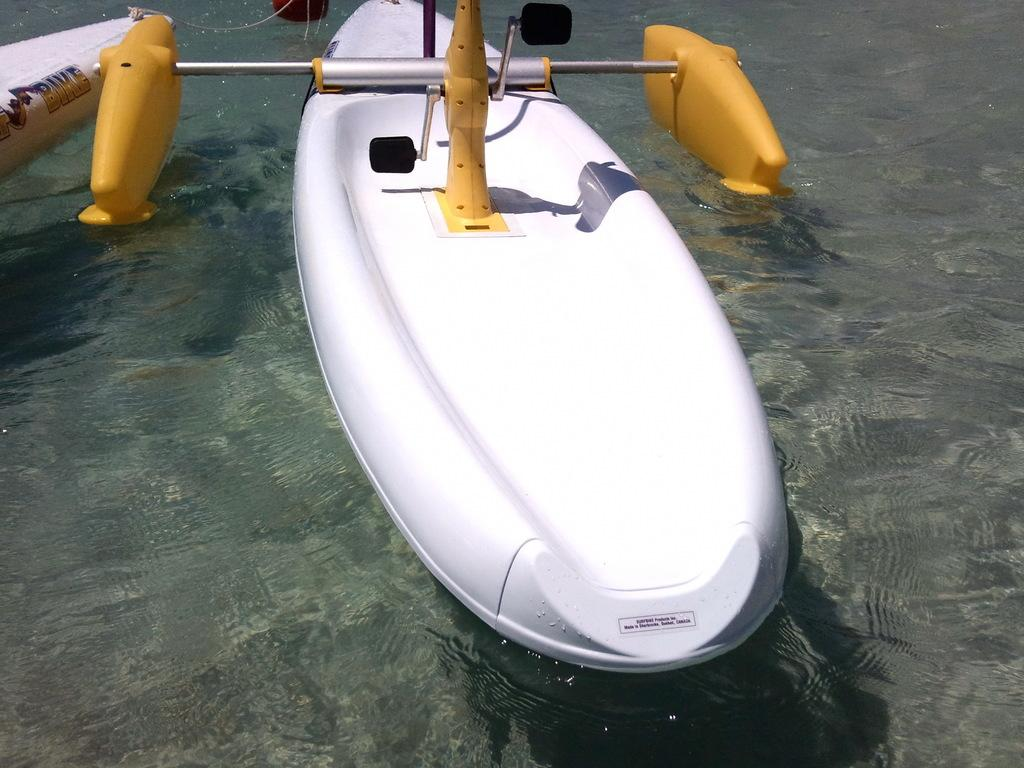What type of vehicles are in the image? There are boats in the image. What is the position of the boats in relation to the water? The boats are above the water. What objects can be seen at the top of the image? There are rods and a pedal visible at the top of the image. What type of church can be seen near the river in the image? There is no church or river present in the image; it features boats above the water with rods and a pedal visible at the top. What type of brass instrument is being played by the musicians in the image? There are no musicians or brass instruments present in the image. 